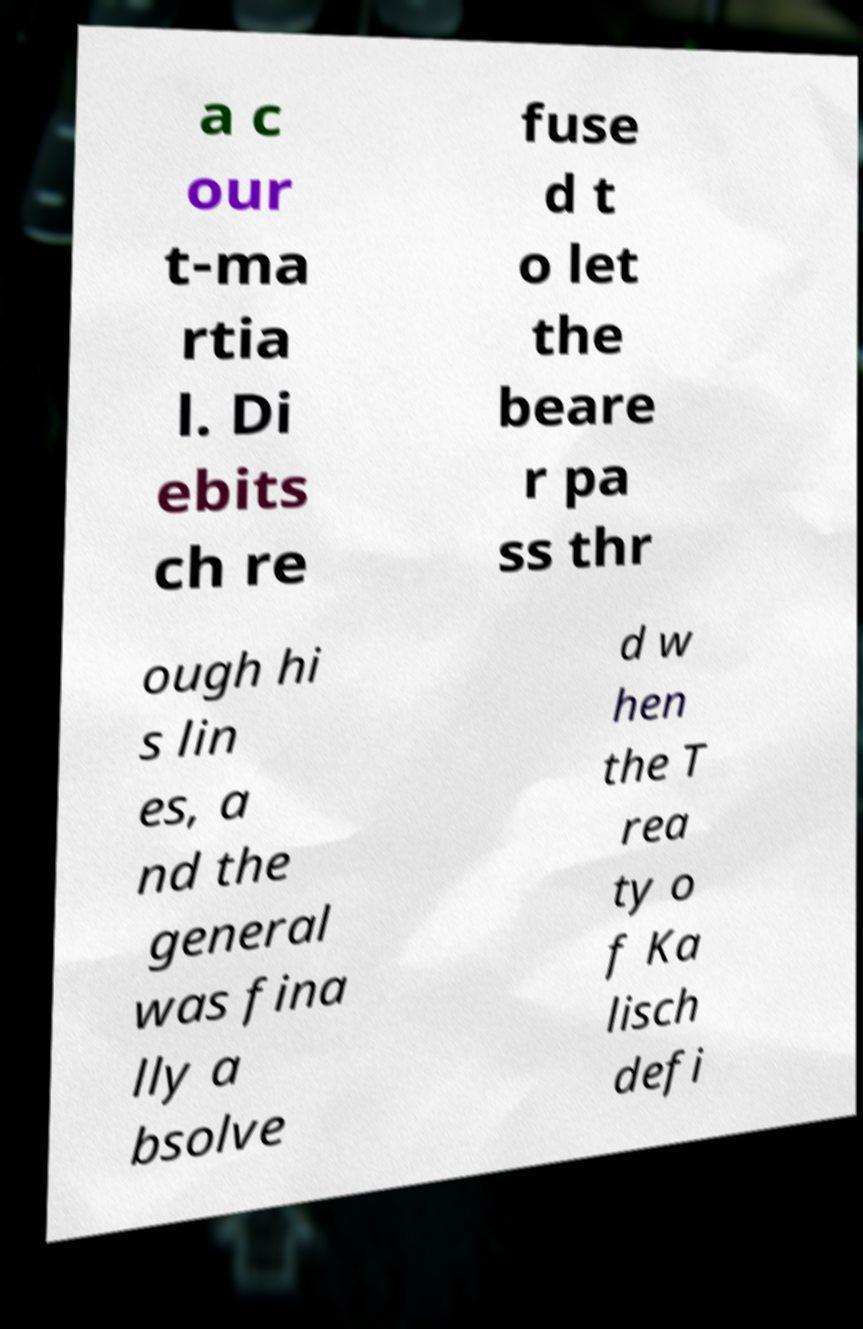Could you extract and type out the text from this image? a c our t-ma rtia l. Di ebits ch re fuse d t o let the beare r pa ss thr ough hi s lin es, a nd the general was fina lly a bsolve d w hen the T rea ty o f Ka lisch defi 